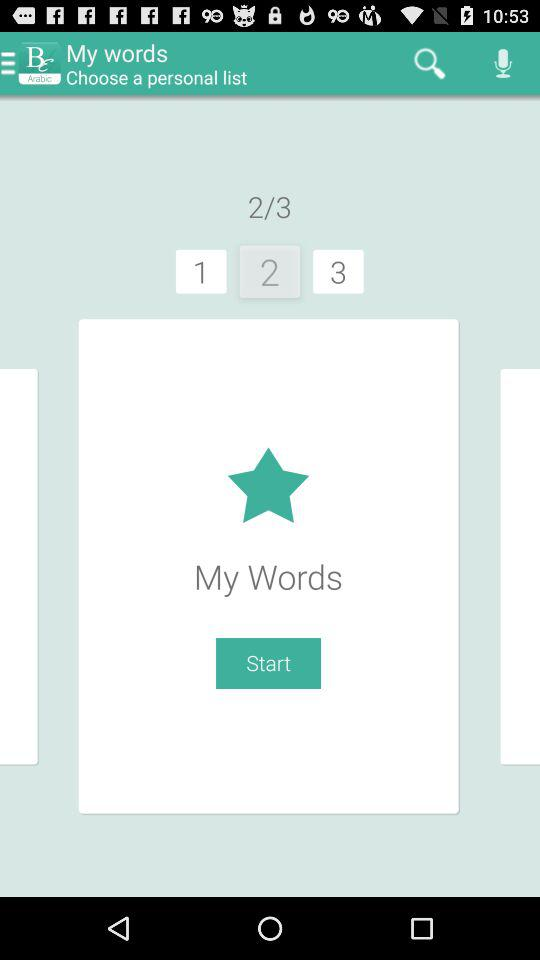Which words are my words?
When the provided information is insufficient, respond with <no answer>. <no answer> 